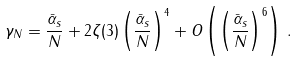Convert formula to latex. <formula><loc_0><loc_0><loc_500><loc_500>\gamma _ { N } = \frac { { \bar { \alpha } } _ { s } } { N } + 2 \zeta ( 3 ) \left ( \frac { { \bar { \alpha } } _ { s } } { N } \right ) ^ { 4 } + O \left ( \left ( \frac { { \bar { \alpha } } _ { s } } { N } \right ) ^ { 6 } \right ) \, .</formula> 